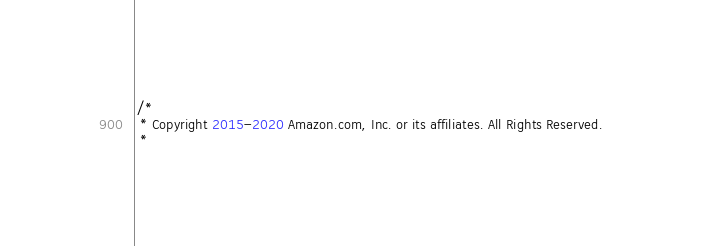Convert code to text. <code><loc_0><loc_0><loc_500><loc_500><_Java_>/*
 * Copyright 2015-2020 Amazon.com, Inc. or its affiliates. All Rights Reserved.
 * </code> 